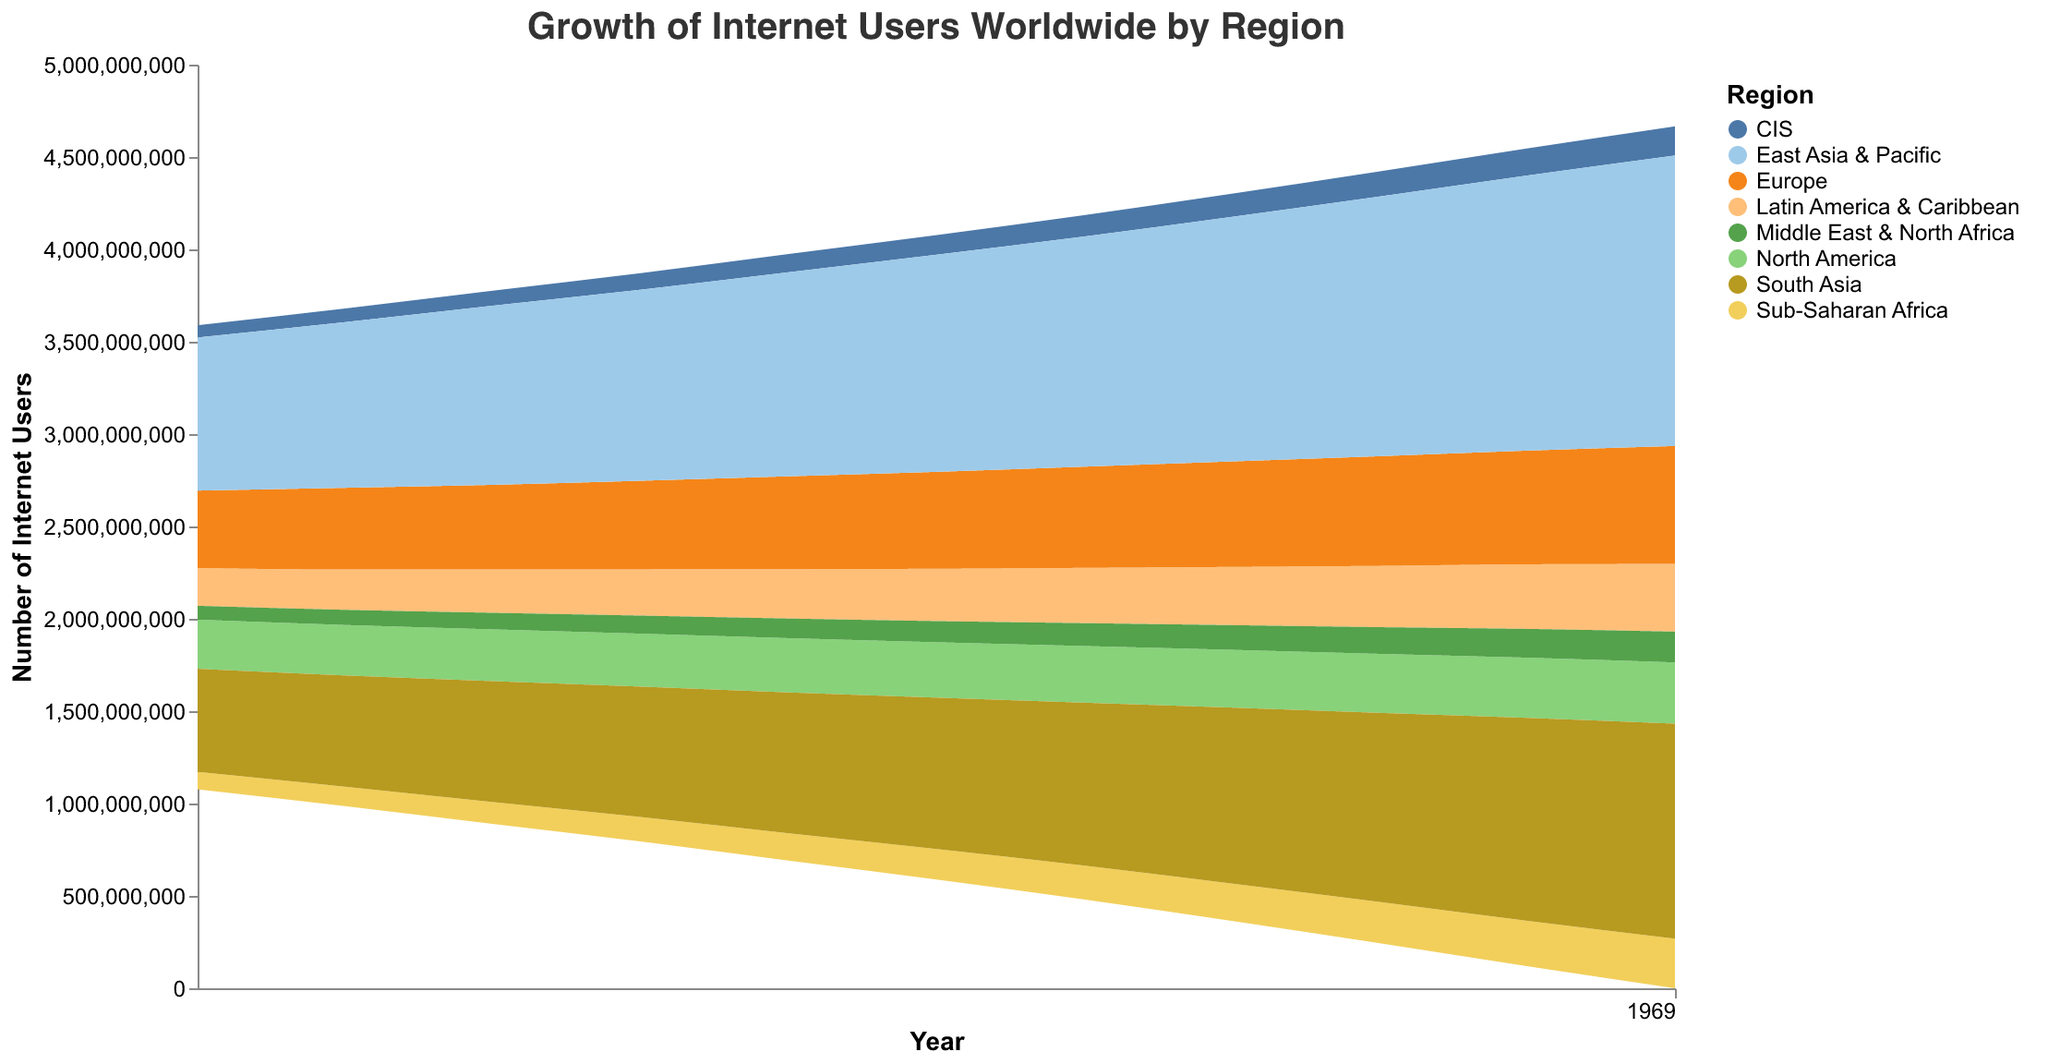What is the title of the graph? The graph's title is usually found at the top, clearly indicating what the graph represents. In this case, the title explicitly states the subject of the visualization.
Answer: Growth of Internet Users Worldwide by Region Which region had the highest number of internet users in 2010? By looking at the different colored regions in the year 2010, we can identify which area has the widest section, representing the highest number of users.
Answer: East Asia & Pacific In which year did South Asia surpass 1 billion internet users? Inspect the area representing South Asia and note the point in time on the x-axis when the users exceeded 1 billion.
Answer: 2018 How did the number of internet users in Sub-Saharan Africa change from 2010 to 2020? Compare the height or value of the Sub-Saharan Africa section at the start and end of the timeline, noting the difference.
Answer: Increased from 94,854,000 to 268,354,000 Which region shows the most significant growth in the number of internet users between 2010 and 2020? Calculate the difference in the number of internet users for each region from 2010 to 2020 and identify the region with the largest growth.
Answer: East Asia & Pacific How does the growth trend of internet users in Europe compare to North America from 2010 to 2020? Observe the relative slopes of the areas representing Europe and North America over the timeline. Compare the gradient and width of both regions.
Answer: Europe's growth is steeper and more significant What is the approximate total number of internet users worldwide in 2015? Sum the segments of all the regions for the year 2015 to get the total number of internet users.
Answer: Approximately 2,742,839,000 Which region had the least fluctuation in internet user growth from 2010 to 2020? Look for the region with the most consistent or uniform growth over time, which will have a relatively smooth and even area representation.
Answer: North America Identify the trend of internet users for the Middle East & North Africa from 2014 to 2018. Examine the section representing Middle East & North Africa and note the change in size from 2014 to 2018, assessing whether it increases or decreases.
Answer: Steadily increasing By how much did Latin America & Caribbean's internet user base increase from 2010 to 2020? Subtract the number of internet users in 2010 for Latin America & Caribbean from the number in 2020.
Answer: Increased by 162,100,000 